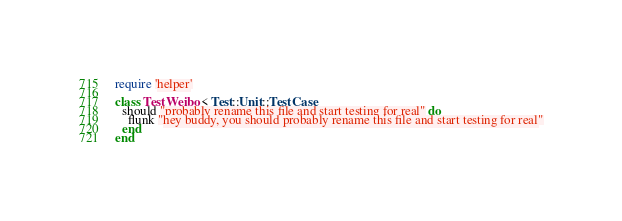<code> <loc_0><loc_0><loc_500><loc_500><_Ruby_>require 'helper'

class TestWeibo < Test::Unit::TestCase
  should "probably rename this file and start testing for real" do
    flunk "hey buddy, you should probably rename this file and start testing for real"
  end
end
</code> 